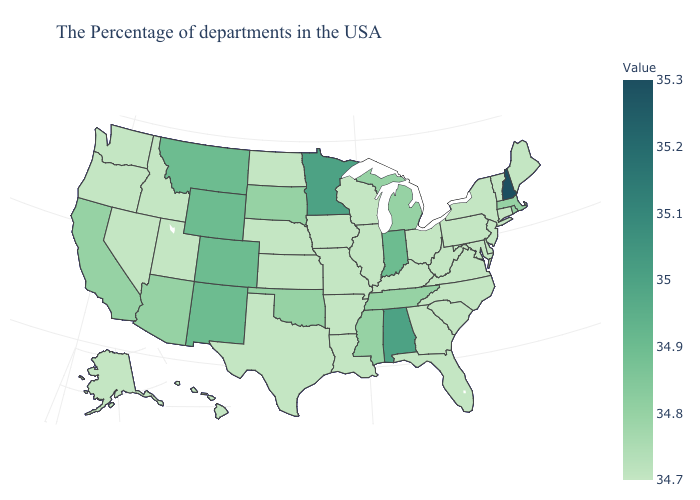Among the states that border Vermont , does New Hampshire have the highest value?
Give a very brief answer. Yes. Does Tennessee have the lowest value in the USA?
Concise answer only. No. Does New Hampshire have the highest value in the USA?
Quick response, please. Yes. Does Oregon have the lowest value in the West?
Write a very short answer. Yes. Does Ohio have the highest value in the MidWest?
Short answer required. No. Which states have the lowest value in the USA?
Write a very short answer. Maine, Vermont, Connecticut, New York, New Jersey, Delaware, Maryland, Pennsylvania, Virginia, North Carolina, South Carolina, West Virginia, Ohio, Florida, Georgia, Kentucky, Wisconsin, Illinois, Louisiana, Missouri, Arkansas, Iowa, Kansas, Nebraska, Texas, North Dakota, Utah, Idaho, Nevada, Washington, Oregon, Alaska, Hawaii. Among the states that border Arkansas , does Tennessee have the lowest value?
Quick response, please. No. Is the legend a continuous bar?
Quick response, please. Yes. 